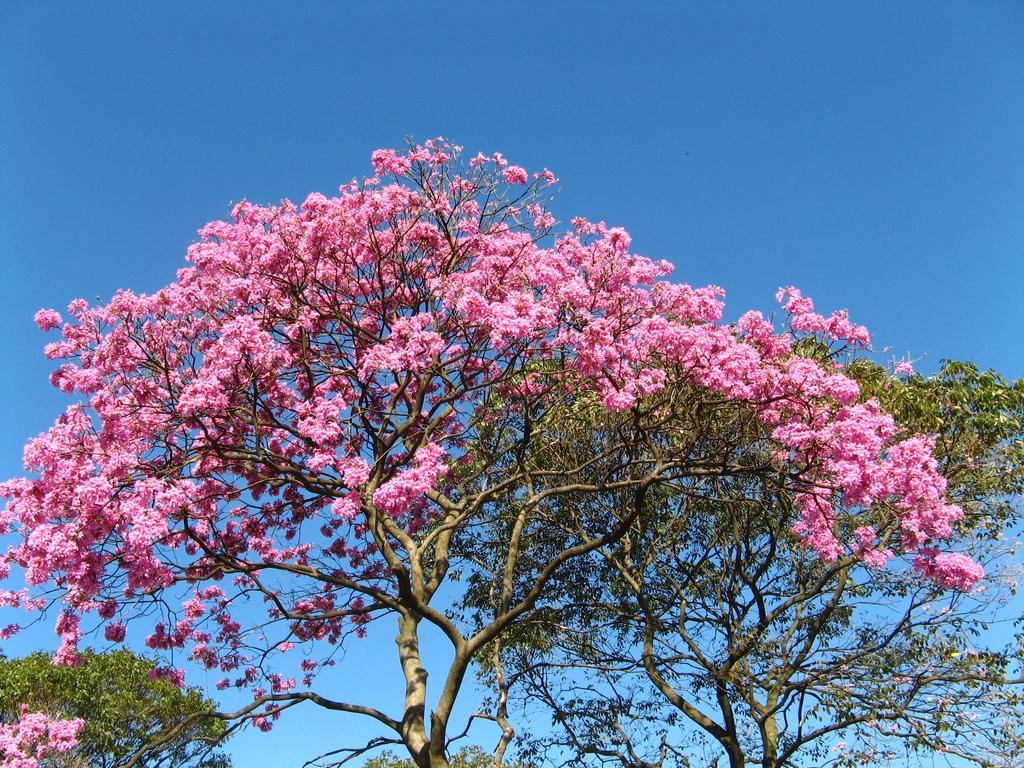In one or two sentences, can you explain what this image depicts? In this picture we can see trees and flowers, there is the sky in the background. 